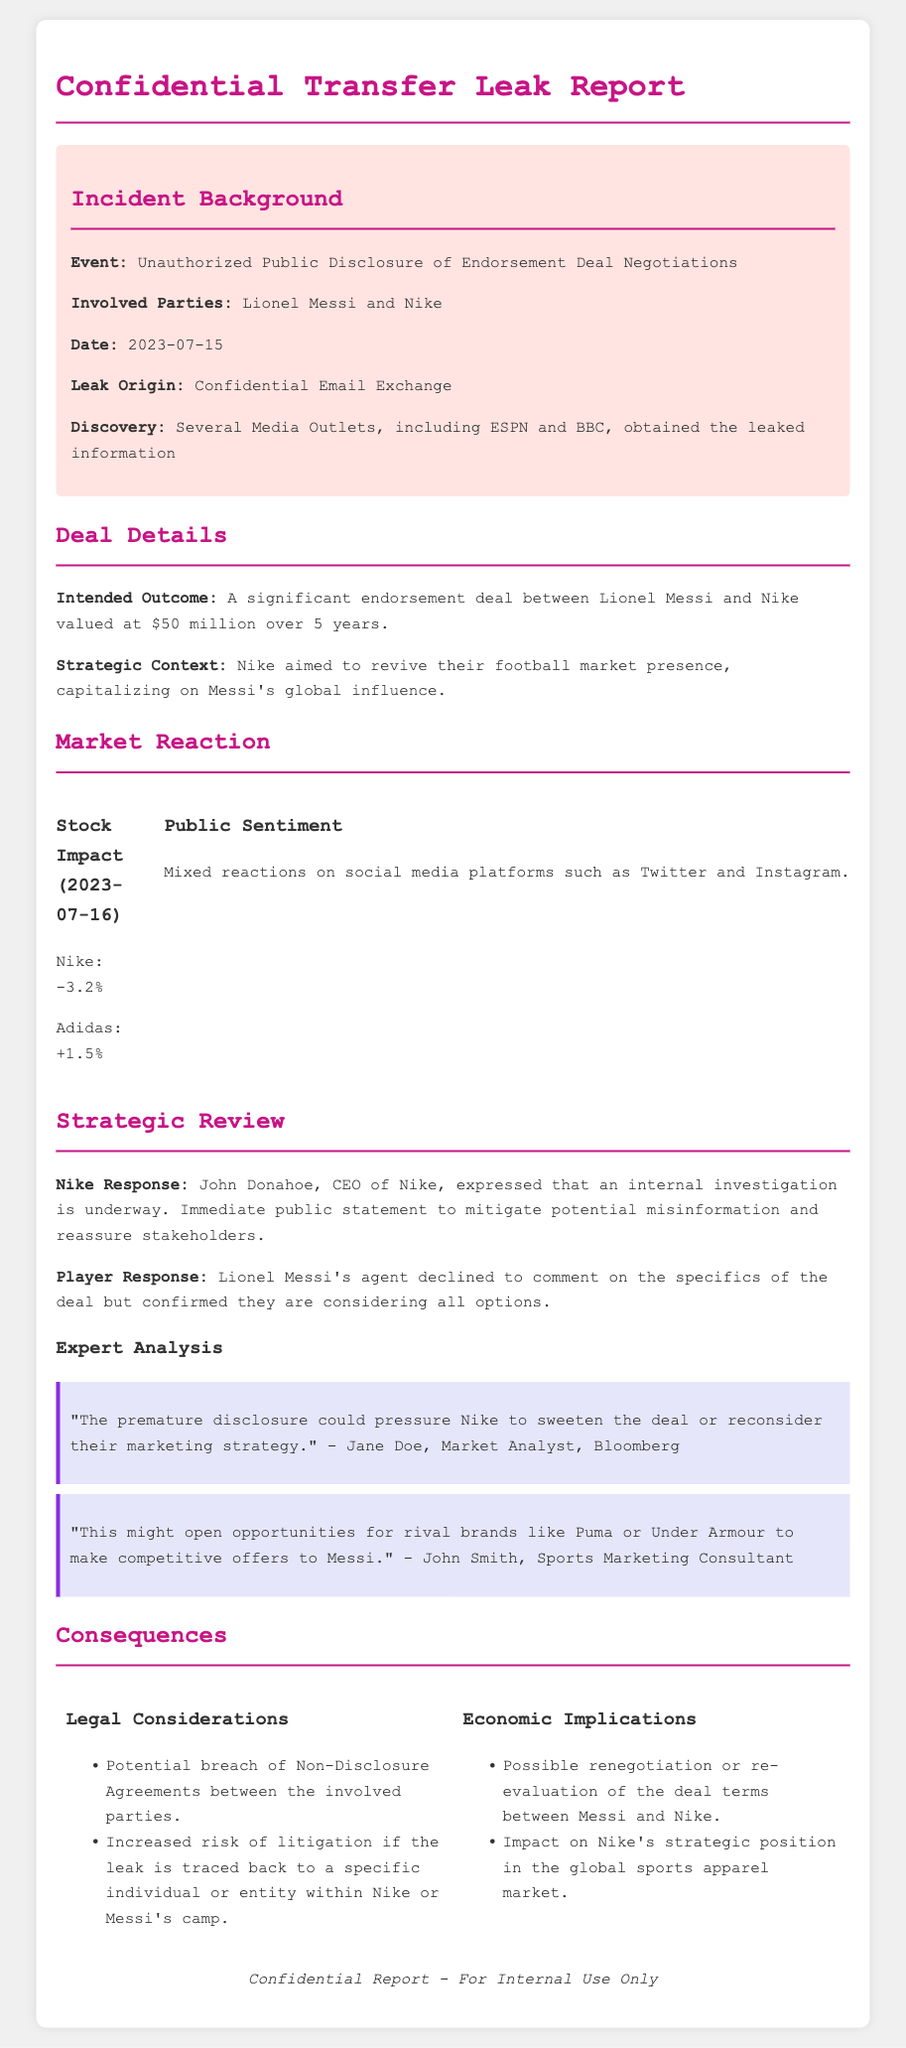What was the date of the incident? The incident date is explicitly stated in the document under the incident details.
Answer: 2023-07-15 Who are the involved parties in the endorsement deal? The document lists the parties involved in the unauthorized disclosure, which is crucial for context.
Answer: Lionel Messi and Nike What was the intended value of the endorsement deal? The intended value is mentioned in the deal details section and reflects the financial implications.
Answer: $50 million What was Nike's stock impact on July 16, 2023? The stock impact is clearly illustrated in the market reaction section, showing immediate financial consequences.
Answer: -3.2% What is the consequence related to legal considerations? The legal consequences outlined explicitly highlight potential risks caused by the leak.
Answer: Potential breach of Non-Disclosure Agreements What did Nike's CEO state regarding the incident? The CEO's response is a critical element of the strategic review, offering insight into corporate actions post-incident.
Answer: An internal investigation is underway What could happen to Messi's deal as a result of the leak? This reflects potential future consequences as indicated in the economic implications section of the report.
Answer: Possible renegotiation or re-evaluation of the deal terms What is the public sentiment on social media platforms after the leak? Understanding public sentiment is vital for assessing market reaction and it is summarized in the document.
Answer: Mixed reactions 